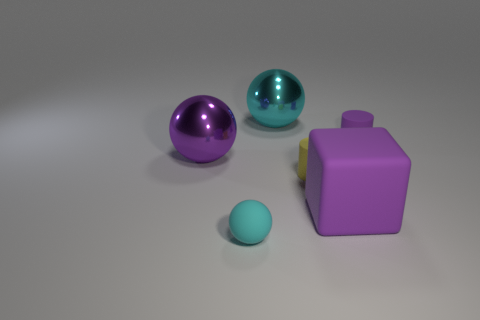How many other things are the same color as the rubber block?
Provide a short and direct response. 2. Is the number of purple shiny balls on the left side of the purple sphere less than the number of tiny purple things?
Provide a short and direct response. Yes. Are there any purple matte cylinders of the same size as the purple rubber block?
Your answer should be very brief. No. There is a block; is it the same color as the matte object that is left of the cyan shiny ball?
Provide a short and direct response. No. There is a cyan sphere behind the yellow cylinder; what number of small purple matte cylinders are on the left side of it?
Make the answer very short. 0. There is a big object to the right of the big metallic thing to the right of the cyan rubber ball; what is its color?
Ensure brevity in your answer.  Purple. What is the material of the thing that is both behind the yellow rubber cylinder and on the right side of the large cyan ball?
Give a very brief answer. Rubber. Are there any tiny gray matte objects of the same shape as the purple shiny object?
Keep it short and to the point. No. Does the small purple matte thing behind the purple ball have the same shape as the purple metallic object?
Provide a short and direct response. No. What number of objects are both in front of the large cyan metallic ball and on the left side of the rubber cube?
Keep it short and to the point. 3. 